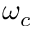Convert formula to latex. <formula><loc_0><loc_0><loc_500><loc_500>\omega _ { c }</formula> 